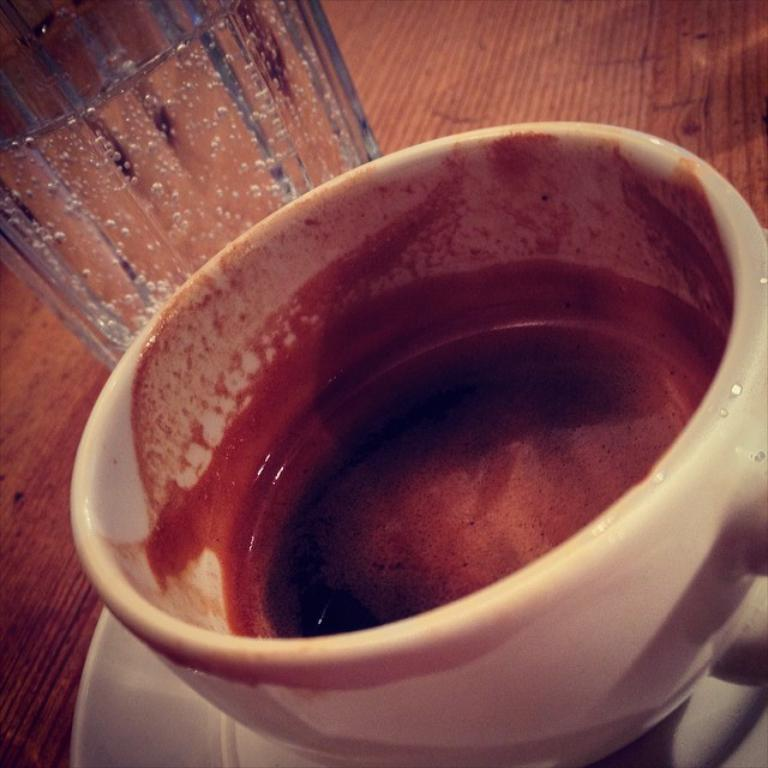What type of dishware is visible in the image? There is a cup and saucer in the image. What other type of container is present in the image? There is a glass in the image. What is the color of the surface on which the cup, saucer, and glass are placed? The cup, saucer, and glass are on a brown color surface. What type of root can be seen growing in the image? There is no root present in the image; it features a cup, saucer, and glass on a brown surface. How many clams are visible in the image? There are no clams present in the image. 